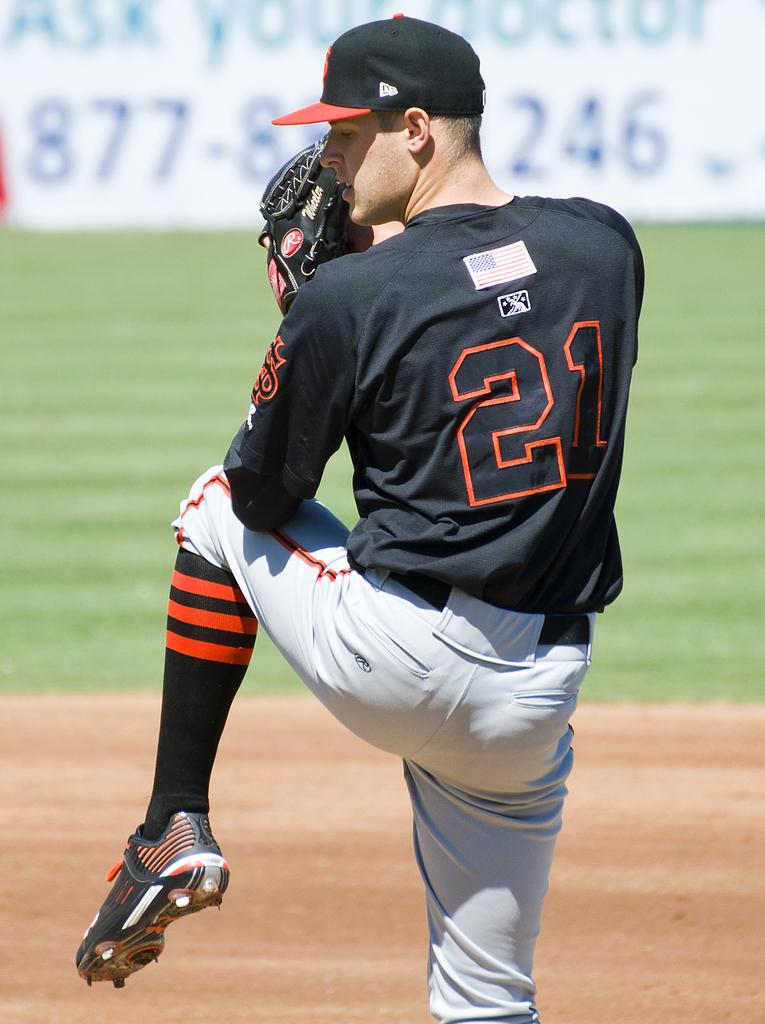What number is this player?
Provide a short and direct response. 21. What is the three digit number in blue on the white sign?
Provide a short and direct response. 246. 